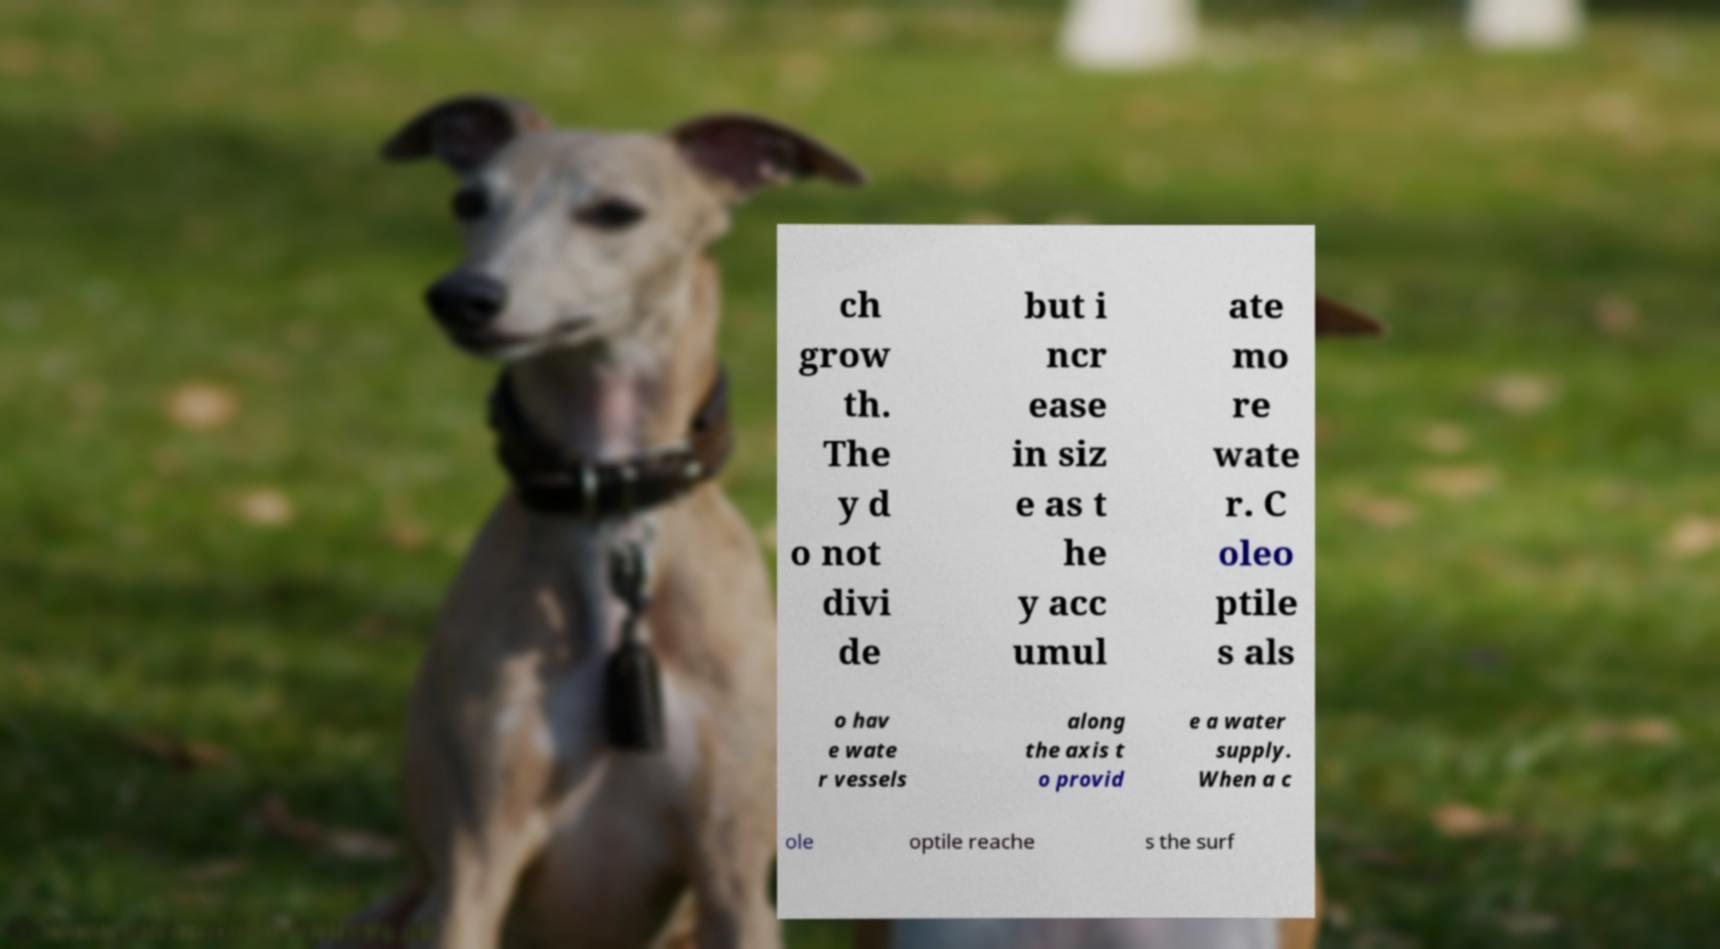Can you accurately transcribe the text from the provided image for me? ch grow th. The y d o not divi de but i ncr ease in siz e as t he y acc umul ate mo re wate r. C oleo ptile s als o hav e wate r vessels along the axis t o provid e a water supply. When a c ole optile reache s the surf 